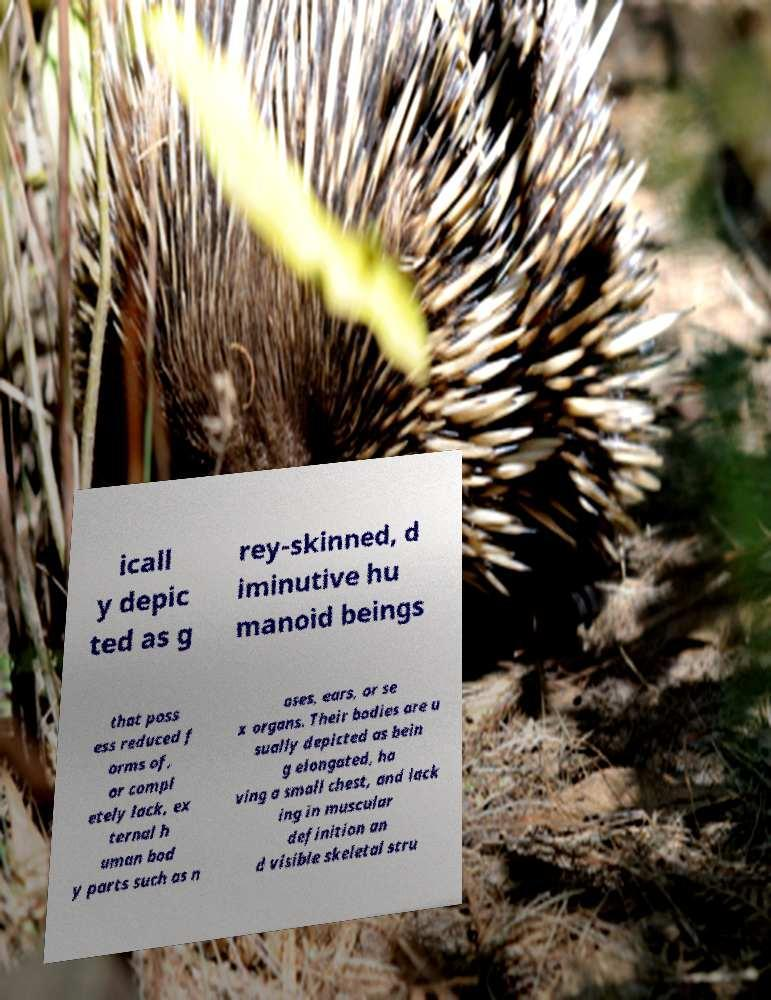For documentation purposes, I need the text within this image transcribed. Could you provide that? icall y depic ted as g rey-skinned, d iminutive hu manoid beings that poss ess reduced f orms of, or compl etely lack, ex ternal h uman bod y parts such as n oses, ears, or se x organs. Their bodies are u sually depicted as bein g elongated, ha ving a small chest, and lack ing in muscular definition an d visible skeletal stru 